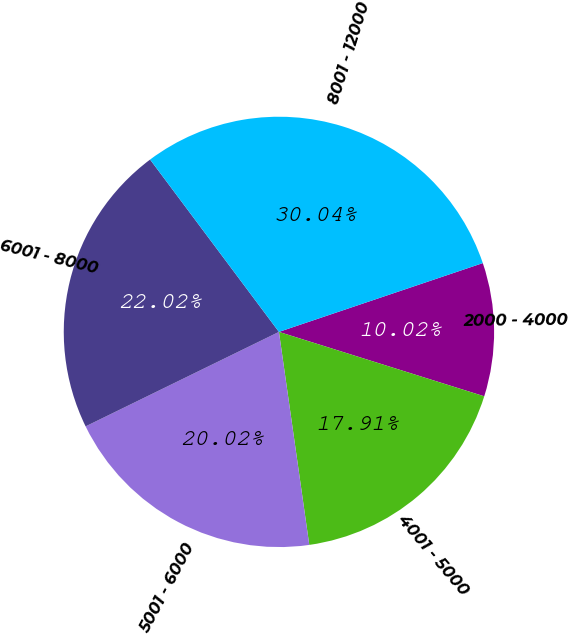Convert chart. <chart><loc_0><loc_0><loc_500><loc_500><pie_chart><fcel>2000 - 4000<fcel>4001 - 5000<fcel>5001 - 6000<fcel>6001 - 8000<fcel>8001 - 12000<nl><fcel>10.02%<fcel>17.91%<fcel>20.02%<fcel>22.02%<fcel>30.04%<nl></chart> 